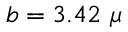Convert formula to latex. <formula><loc_0><loc_0><loc_500><loc_500>b = 3 . 4 2 \mu</formula> 